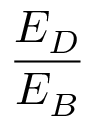Convert formula to latex. <formula><loc_0><loc_0><loc_500><loc_500>\frac { E _ { D } } { E _ { B } }</formula> 